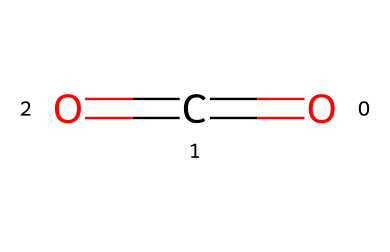What is the chemical name of this compound? The provided SMILES representation corresponds to carbon dioxide, which is a common name for the compound with the structure O=C=O.
Answer: carbon dioxide How many oxygen atoms are present in the molecule? Analyzing the SMILES string O=C=O, we see there are two oxygen atoms in the structure, positioned at both ends of the carbon atom.
Answer: two What type of bond connects the carbon and oxygen atoms? The structure shows that there are double bonds (indicated by the '=' sign) between carbon and each oxygen atom in the molecule.
Answer: double bond What is the total number of atoms in carbon dioxide? The molecule consists of one carbon atom and two oxygen atoms, totaling three atoms within the structure.
Answer: three Why is carbon dioxide considered a gas at room temperature? The molecular structure of carbon dioxide is nonpolar and consists of small molecules, which leads to weak intermolecular forces, allowing it to exist as a gas at room temperature.
Answer: weak intermolecular forces How does the chemical structure indicate the shape of the molecule? The arrangement of atoms and double bonds suggests that carbon dioxide has a linear shape due to the 180-degree bond angle between the oxygen atoms, influenced by VSEPR theory.
Answer: linear shape What role does this gas play in the animal respiratory process? Carbon dioxide is a byproduct of respiration in animals, indicating that it is produced when they exhale, contributing to the natural carbon cycle in ecosystems.
Answer: byproduct of respiration 